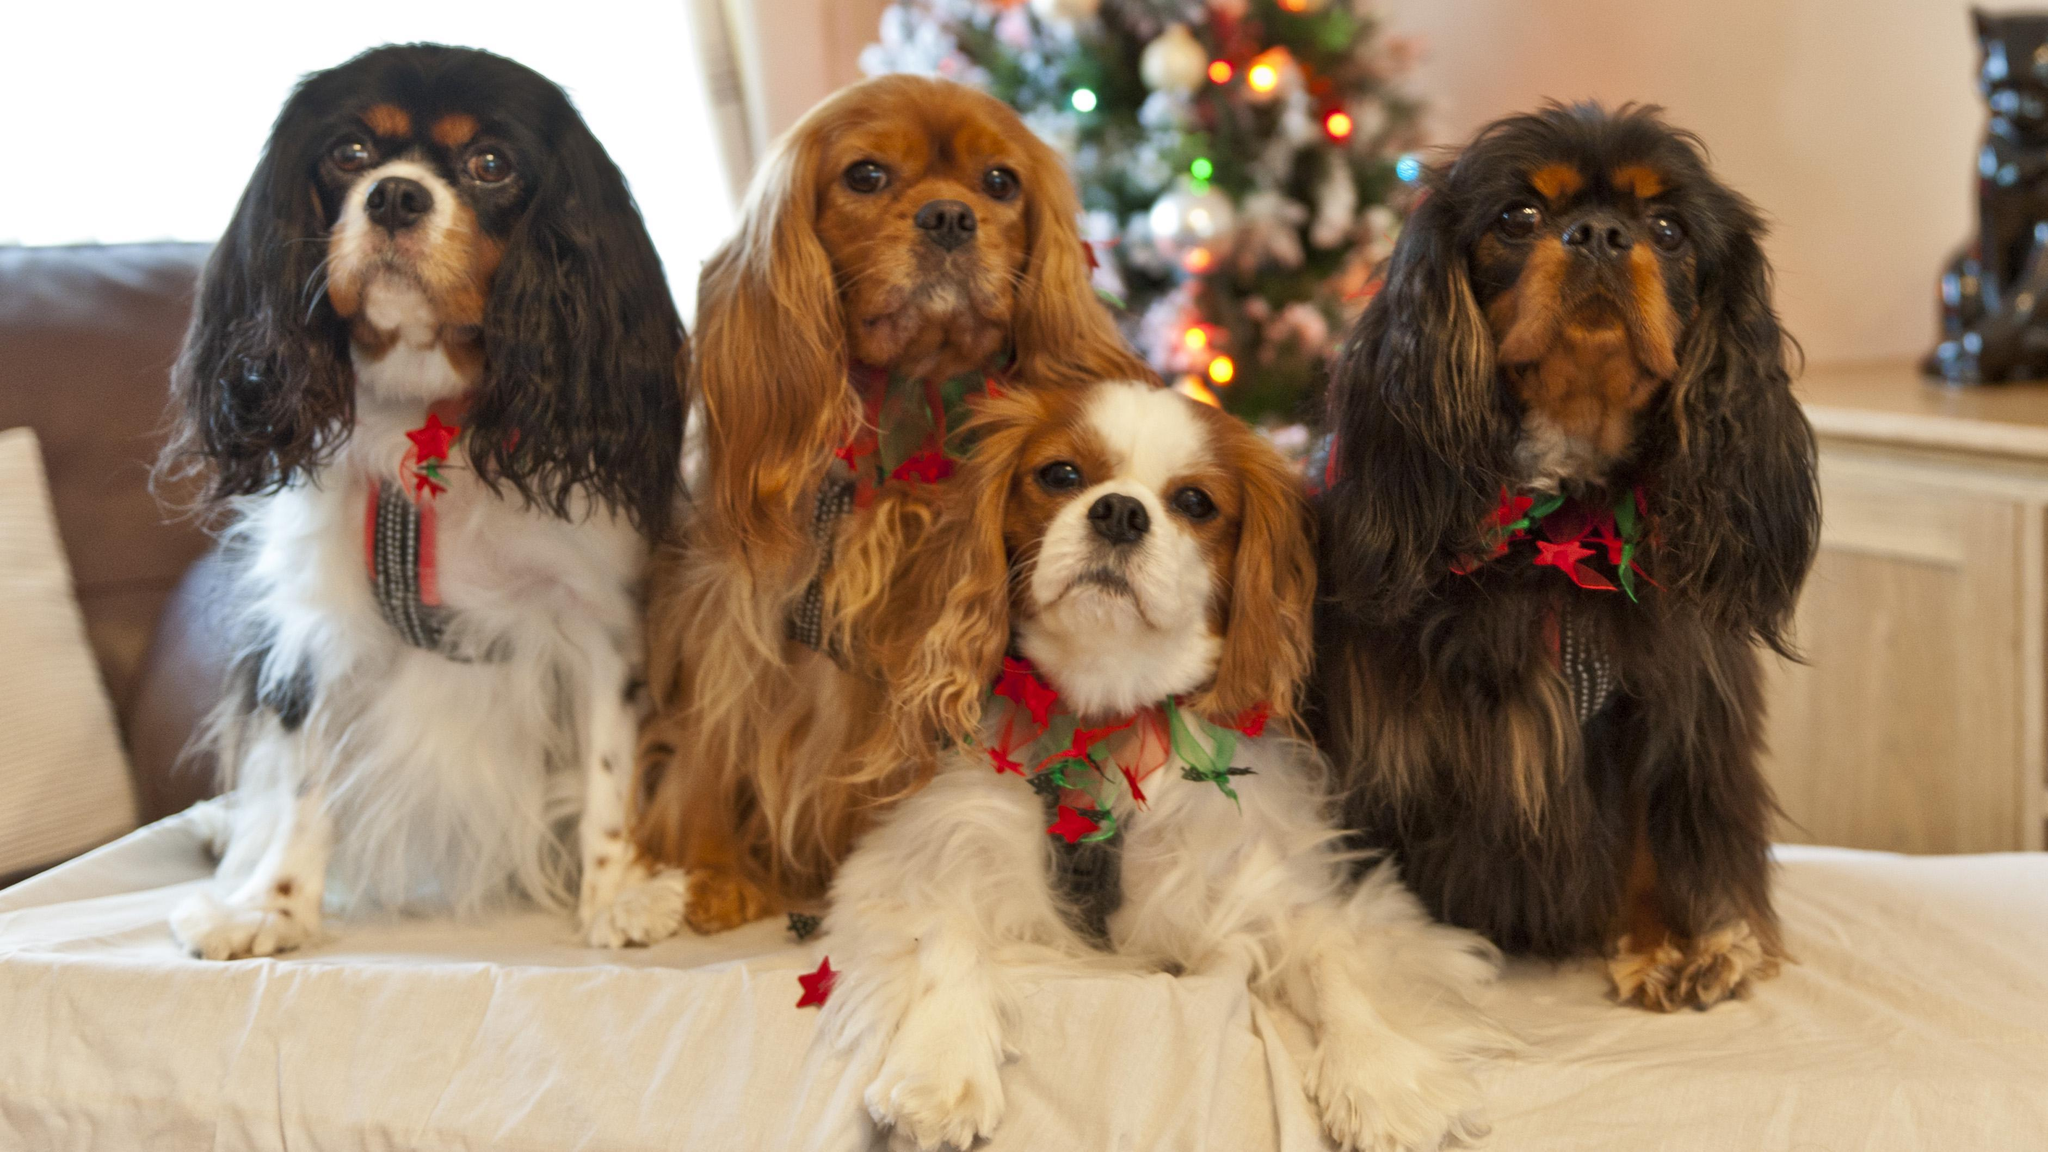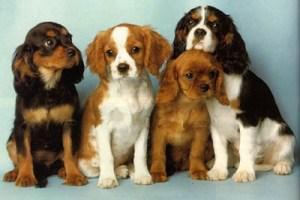The first image is the image on the left, the second image is the image on the right. Assess this claim about the two images: "Each image is a full body shot of four different dogs.". Correct or not? Answer yes or no. Yes. The first image is the image on the left, the second image is the image on the right. For the images shown, is this caption "Four dogs are outside together." true? Answer yes or no. No. 